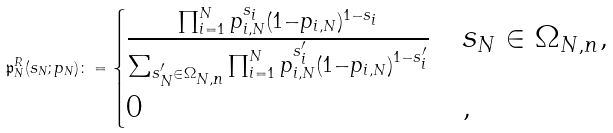<formula> <loc_0><loc_0><loc_500><loc_500>\mathfrak { p } _ { N } ^ { R } ( s _ { N } ; p _ { N } ) \colon = \begin{cases} \frac { \prod _ { i = 1 } ^ { N } p _ { i , N } ^ { s _ { i } } ( 1 - p _ { i , N } ) ^ { 1 - s _ { i } } } { \sum _ { s _ { N } ^ { \prime } \in \Omega _ { N , n } } \prod _ { i = 1 } ^ { N } p _ { i , N } ^ { s _ { i } ^ { \prime } } ( 1 - p _ { i , N } ) ^ { 1 - s _ { i } ^ { \prime } } } & s _ { N } \in \Omega _ { N , n } , \\ 0 & , \end{cases}</formula> 